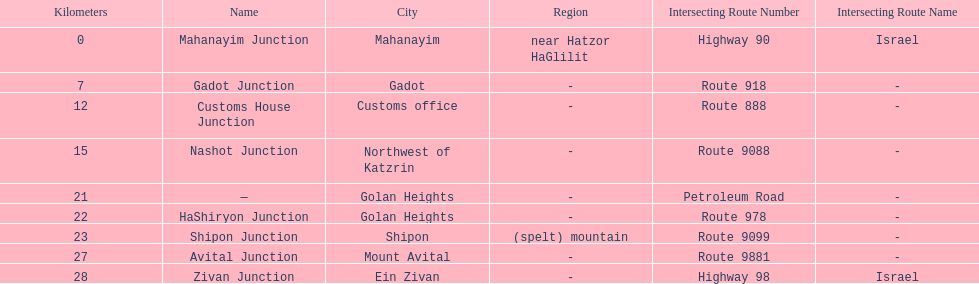What is the last junction on highway 91? Zivan Junction. 